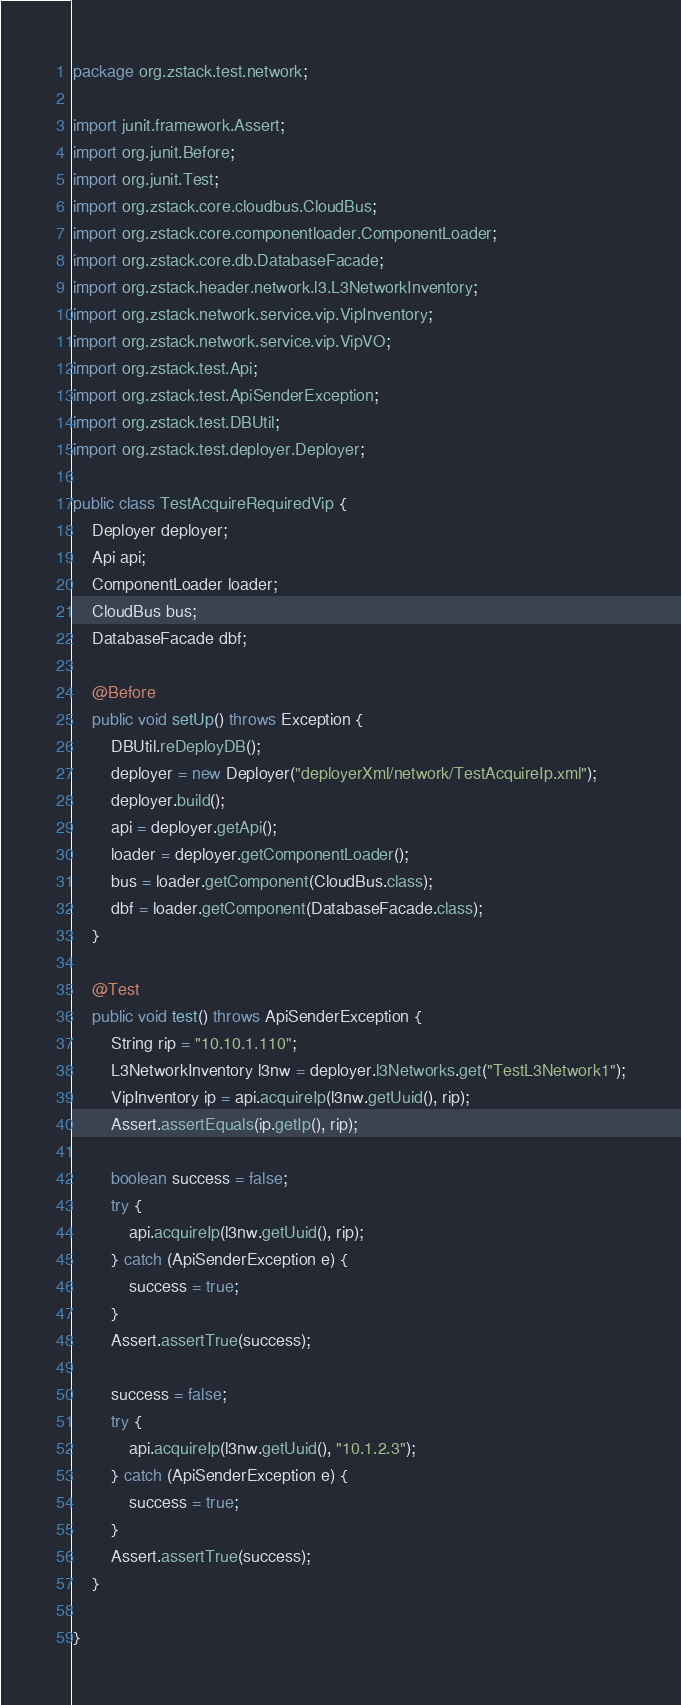<code> <loc_0><loc_0><loc_500><loc_500><_Java_>package org.zstack.test.network;

import junit.framework.Assert;
import org.junit.Before;
import org.junit.Test;
import org.zstack.core.cloudbus.CloudBus;
import org.zstack.core.componentloader.ComponentLoader;
import org.zstack.core.db.DatabaseFacade;
import org.zstack.header.network.l3.L3NetworkInventory;
import org.zstack.network.service.vip.VipInventory;
import org.zstack.network.service.vip.VipVO;
import org.zstack.test.Api;
import org.zstack.test.ApiSenderException;
import org.zstack.test.DBUtil;
import org.zstack.test.deployer.Deployer;

public class TestAcquireRequiredVip {
    Deployer deployer;
    Api api;
    ComponentLoader loader;
    CloudBus bus;
    DatabaseFacade dbf;

    @Before
    public void setUp() throws Exception {
        DBUtil.reDeployDB();
        deployer = new Deployer("deployerXml/network/TestAcquireIp.xml");
        deployer.build();
        api = deployer.getApi();
        loader = deployer.getComponentLoader();
        bus = loader.getComponent(CloudBus.class);
        dbf = loader.getComponent(DatabaseFacade.class);
    }
    
    @Test
    public void test() throws ApiSenderException {
        String rip = "10.10.1.110";
        L3NetworkInventory l3nw = deployer.l3Networks.get("TestL3Network1");
        VipInventory ip = api.acquireIp(l3nw.getUuid(), rip);
        Assert.assertEquals(ip.getIp(), rip);

        boolean success = false;
        try {
            api.acquireIp(l3nw.getUuid(), rip);
        } catch (ApiSenderException e) {
            success = true;
        }
        Assert.assertTrue(success);

        success = false;
        try {
            api.acquireIp(l3nw.getUuid(), "10.1.2.3");
        } catch (ApiSenderException e) {
            success = true;
        }
        Assert.assertTrue(success);
    }

}
</code> 